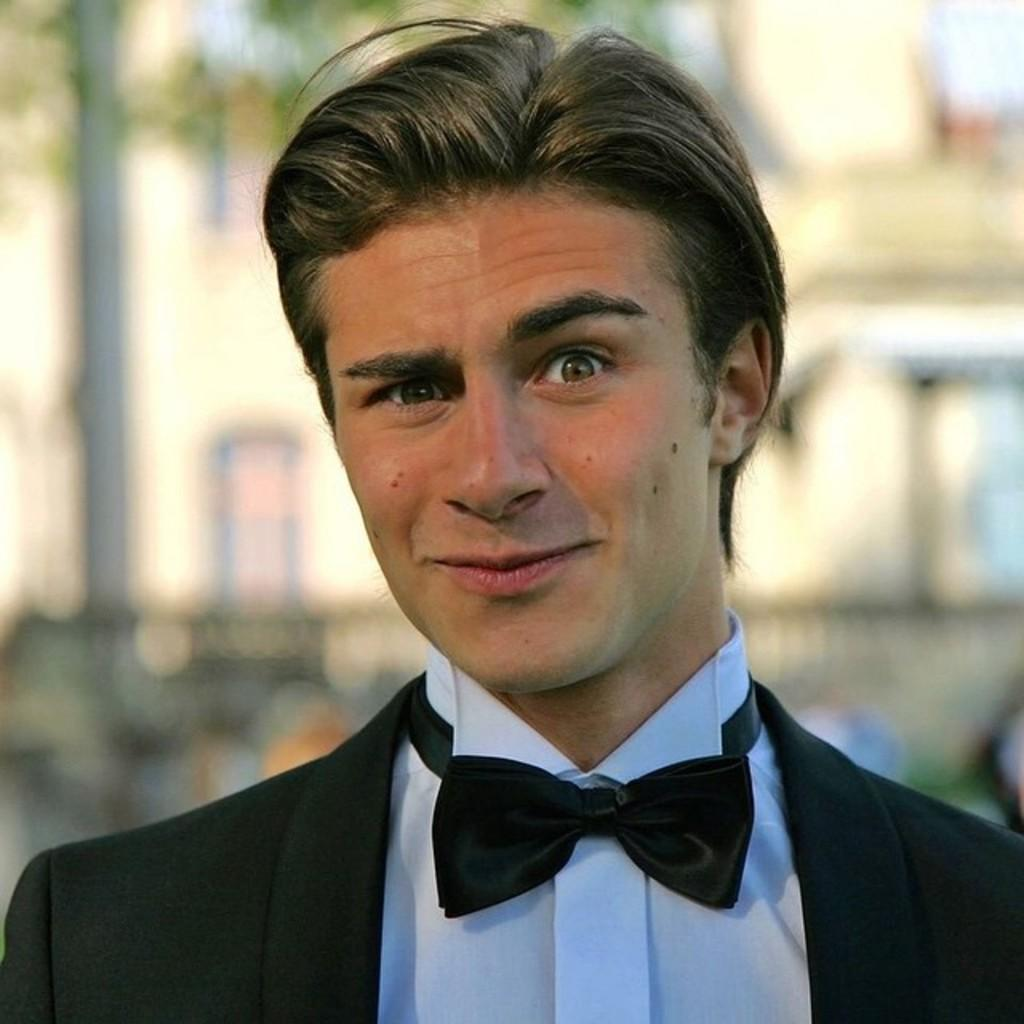Who is present in the image? There is a man in the image. What is the man's facial expression? The man is smiling. What can be seen in the distance behind the man? There is a building in the background of the image. How would you describe the background of the image? The background of the image is blurry. What type of sweater is the man wearing in the image? There is no sweater visible in the image; the man is not wearing any clothing. Can you see any bubbles floating around the man in the image? There are no bubbles present in the image. 